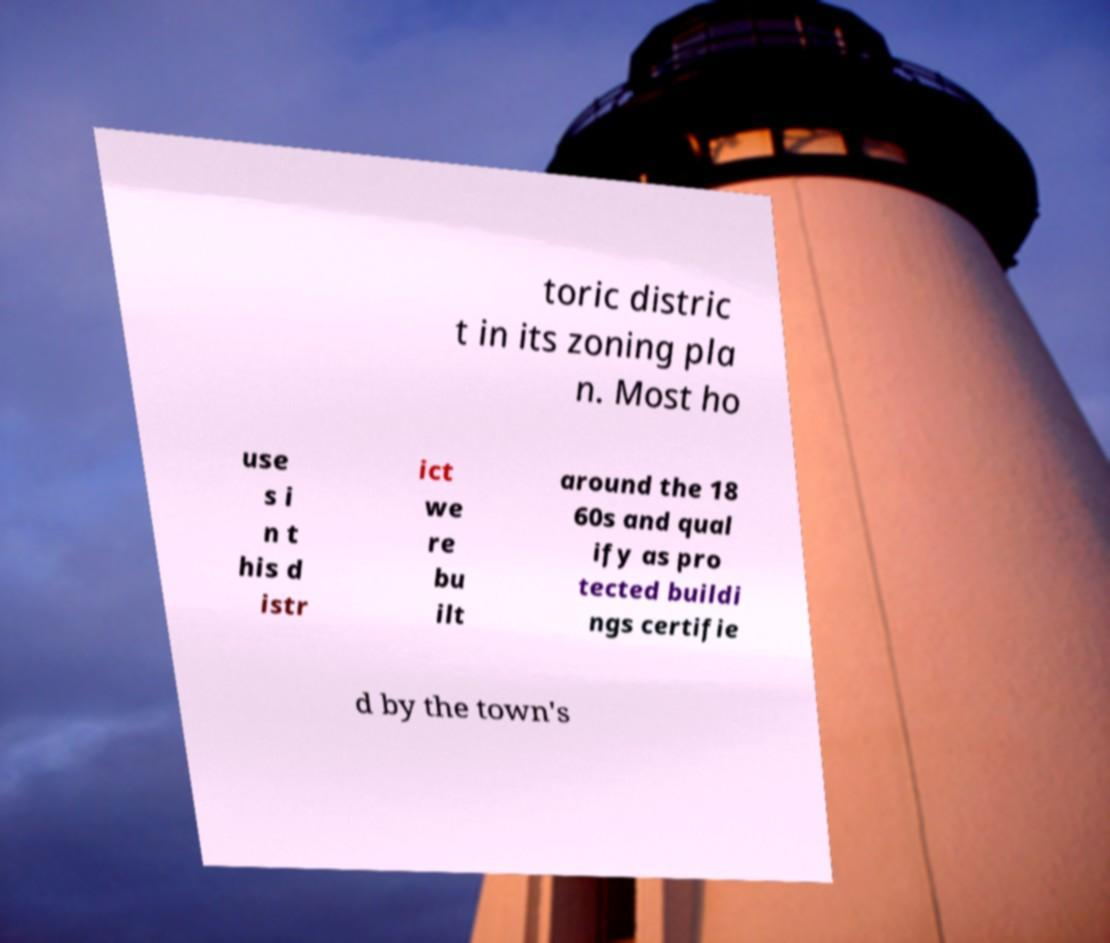Can you read and provide the text displayed in the image?This photo seems to have some interesting text. Can you extract and type it out for me? toric distric t in its zoning pla n. Most ho use s i n t his d istr ict we re bu ilt around the 18 60s and qual ify as pro tected buildi ngs certifie d by the town's 